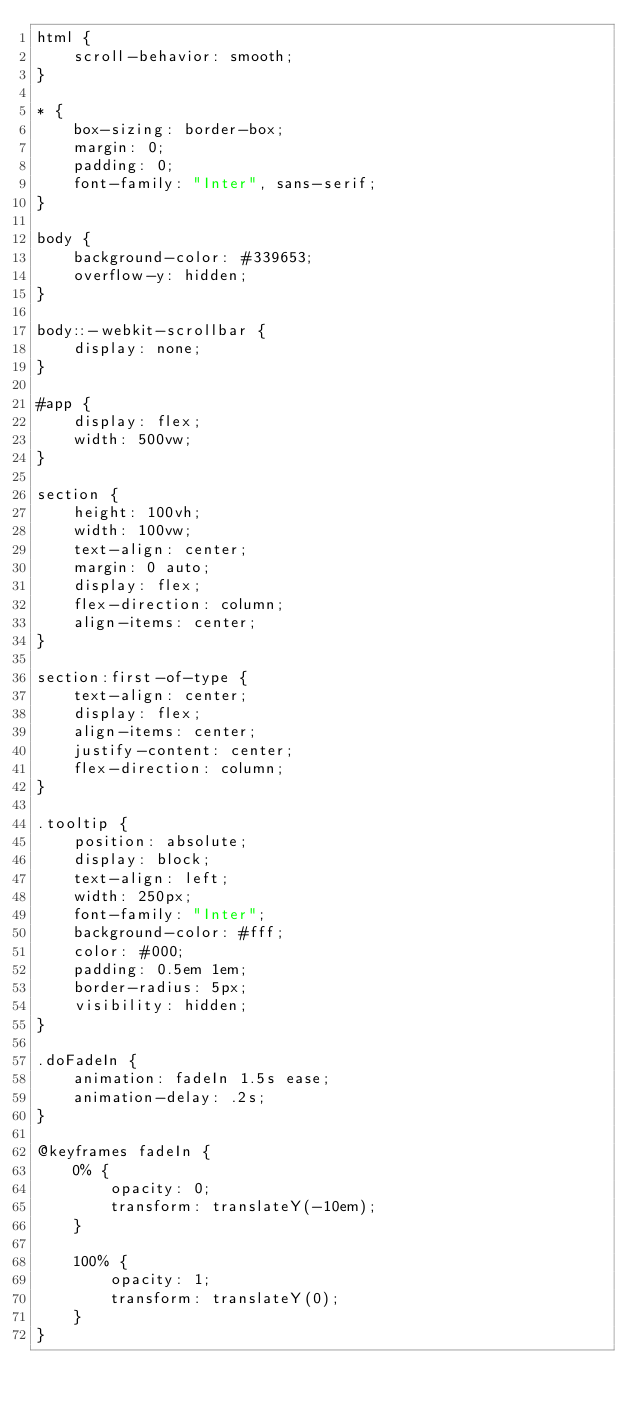<code> <loc_0><loc_0><loc_500><loc_500><_CSS_>html {
    scroll-behavior: smooth;
}

* {
    box-sizing: border-box;
    margin: 0;
    padding: 0;
    font-family: "Inter", sans-serif;
}

body {
    background-color: #339653;
    overflow-y: hidden;
}

body::-webkit-scrollbar {
    display: none;
}

#app {
    display: flex;
    width: 500vw;
}

section {
    height: 100vh;
    width: 100vw;
    text-align: center;
    margin: 0 auto;
    display: flex;
    flex-direction: column;
    align-items: center;
}

section:first-of-type {
    text-align: center;
    display: flex;
    align-items: center;
    justify-content: center;
    flex-direction: column;
}

.tooltip {
    position: absolute;
    display: block;
    text-align: left;
    width: 250px;
    font-family: "Inter";
    background-color: #fff;
    color: #000;
    padding: 0.5em 1em;
    border-radius: 5px;
    visibility: hidden;
}

.doFadeIn {
    animation: fadeIn 1.5s ease;
    animation-delay: .2s;
}

@keyframes fadeIn {
    0% {
        opacity: 0;
        transform: translateY(-10em);
    }

    100% {
        opacity: 1;
        transform: translateY(0);
    }
}</code> 